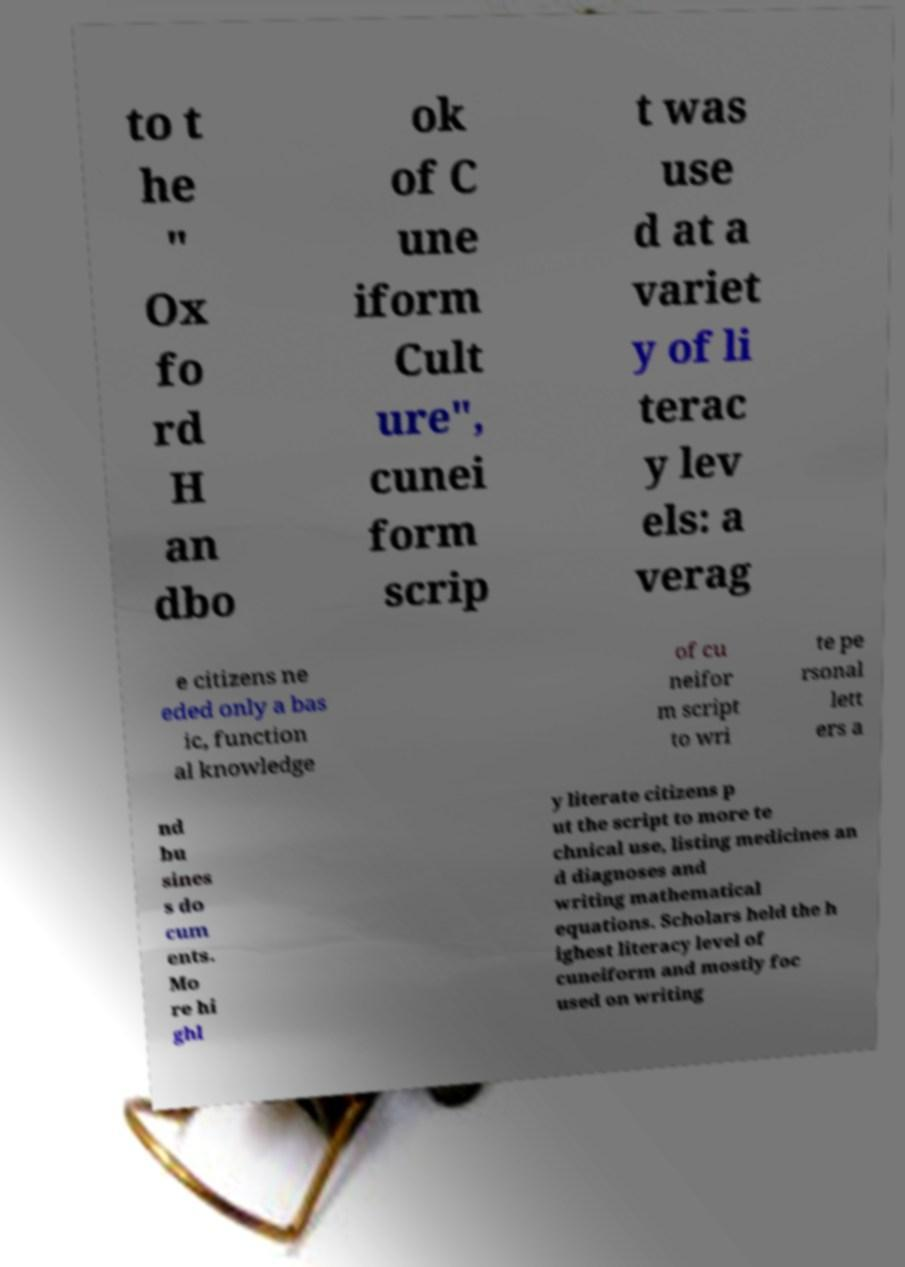Please read and relay the text visible in this image. What does it say? to t he " Ox fo rd H an dbo ok of C une iform Cult ure", cunei form scrip t was use d at a variet y of li terac y lev els: a verag e citizens ne eded only a bas ic, function al knowledge of cu neifor m script to wri te pe rsonal lett ers a nd bu sines s do cum ents. Mo re hi ghl y literate citizens p ut the script to more te chnical use, listing medicines an d diagnoses and writing mathematical equations. Scholars held the h ighest literacy level of cuneiform and mostly foc used on writing 